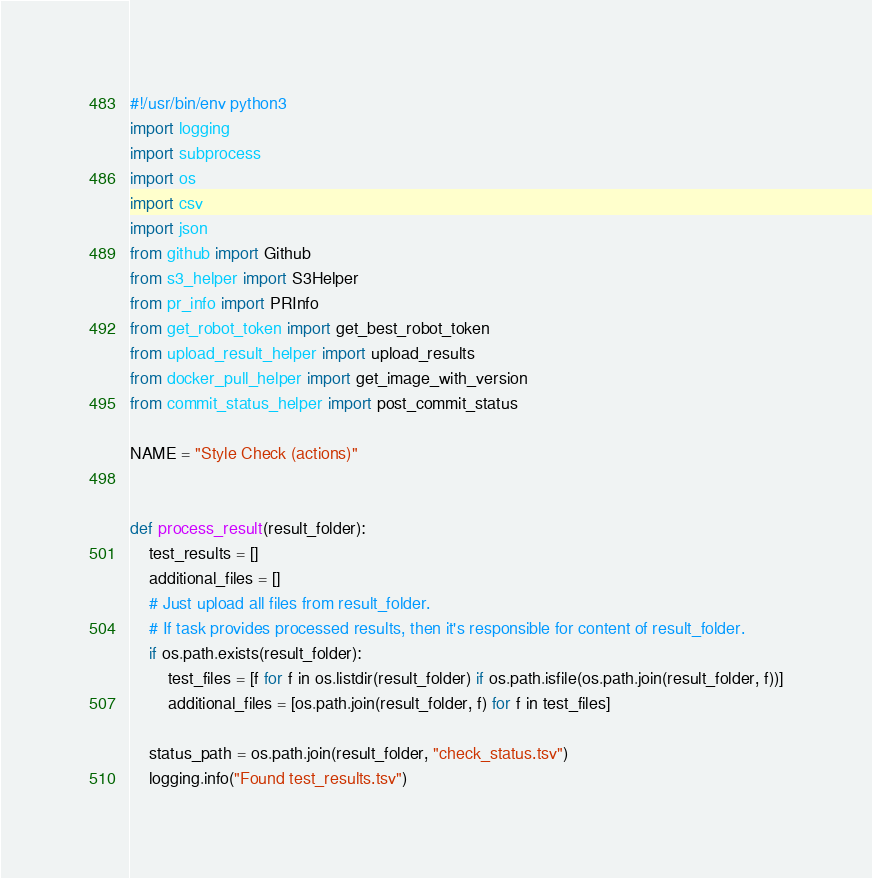<code> <loc_0><loc_0><loc_500><loc_500><_Python_>#!/usr/bin/env python3
import logging
import subprocess
import os
import csv
import json
from github import Github
from s3_helper import S3Helper
from pr_info import PRInfo
from get_robot_token import get_best_robot_token
from upload_result_helper import upload_results
from docker_pull_helper import get_image_with_version
from commit_status_helper import post_commit_status

NAME = "Style Check (actions)"


def process_result(result_folder):
    test_results = []
    additional_files = []
    # Just upload all files from result_folder.
    # If task provides processed results, then it's responsible for content of result_folder.
    if os.path.exists(result_folder):
        test_files = [f for f in os.listdir(result_folder) if os.path.isfile(os.path.join(result_folder, f))]
        additional_files = [os.path.join(result_folder, f) for f in test_files]

    status_path = os.path.join(result_folder, "check_status.tsv")
    logging.info("Found test_results.tsv")</code> 